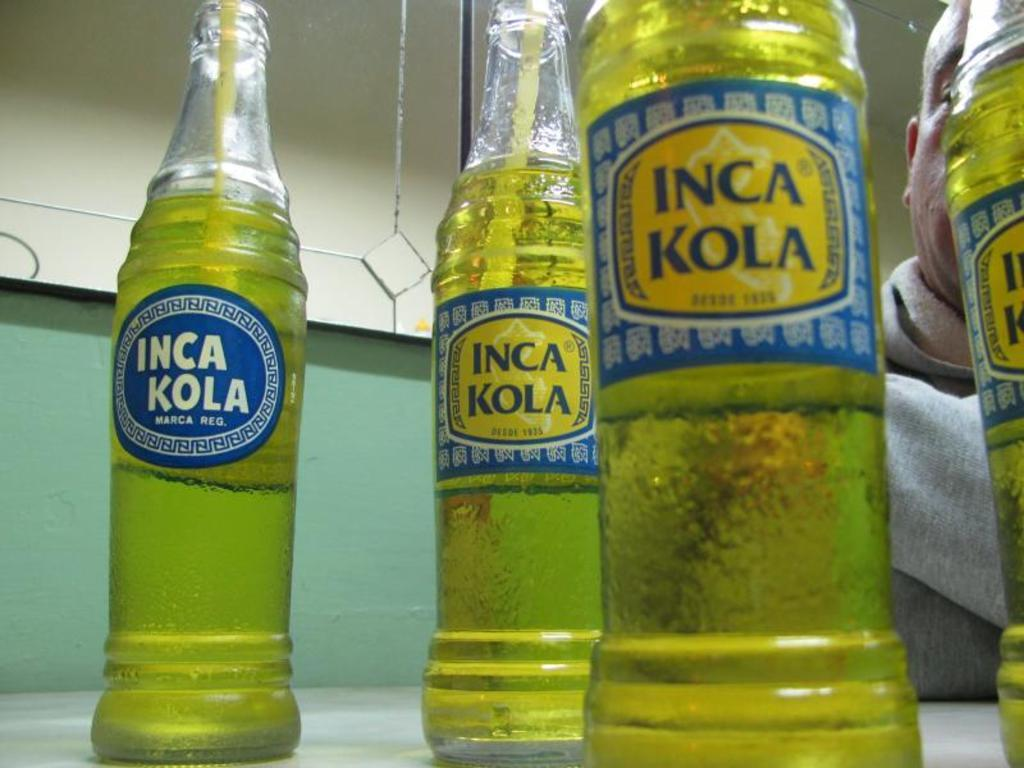<image>
Render a clear and concise summary of the photo. Bottles of liquid with  Inca Kola written on the labels. 